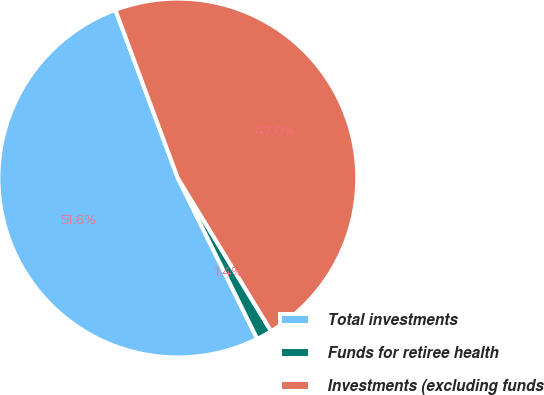<chart> <loc_0><loc_0><loc_500><loc_500><pie_chart><fcel>Total investments<fcel>Funds for retiree health<fcel>Investments (excluding funds<nl><fcel>51.64%<fcel>1.41%<fcel>46.95%<nl></chart> 